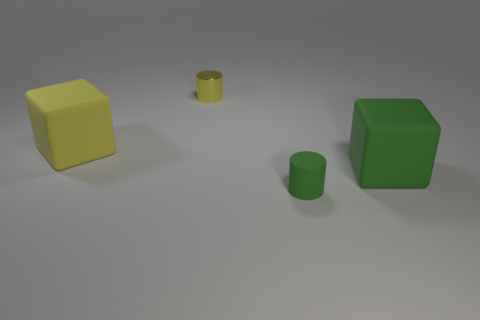Are there the same number of big yellow matte cubes in front of the matte cylinder and big objects to the left of the big yellow rubber block?
Offer a very short reply. Yes. How many yellow things are either matte cylinders or metallic objects?
Ensure brevity in your answer.  1. Is the color of the shiny thing the same as the tiny object that is in front of the yellow cylinder?
Keep it short and to the point. No. What number of other objects are there of the same color as the shiny object?
Give a very brief answer. 1. Are there fewer shiny cylinders than small cyan rubber cylinders?
Keep it short and to the point. No. There is a yellow block in front of the yellow object that is behind the yellow matte thing; what number of yellow cubes are left of it?
Make the answer very short. 0. There is a cylinder behind the large green cube; what size is it?
Provide a short and direct response. Small. Do the object in front of the big green object and the metal object have the same shape?
Offer a very short reply. Yes. There is another big object that is the same shape as the big yellow rubber object; what material is it?
Provide a succinct answer. Rubber. Is there anything else that is the same size as the yellow cube?
Your answer should be compact. Yes. 